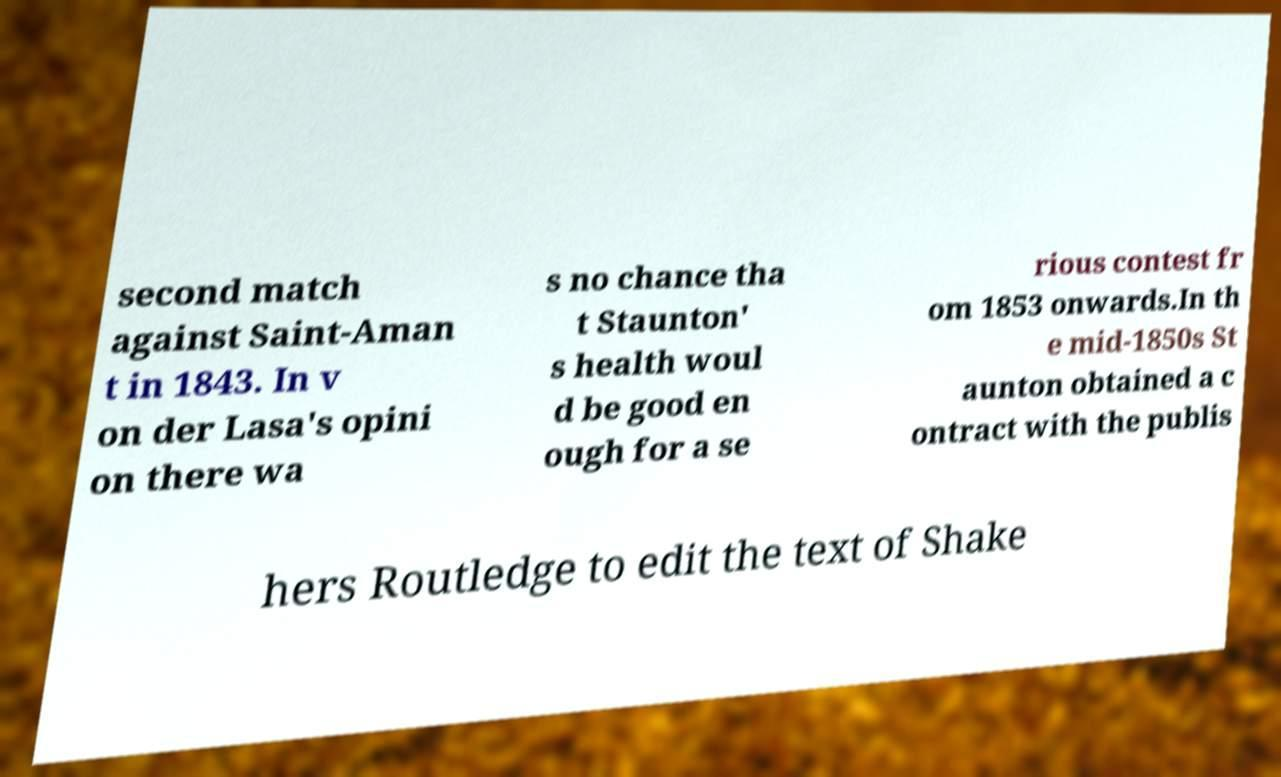Can you accurately transcribe the text from the provided image for me? second match against Saint-Aman t in 1843. In v on der Lasa's opini on there wa s no chance tha t Staunton' s health woul d be good en ough for a se rious contest fr om 1853 onwards.In th e mid-1850s St aunton obtained a c ontract with the publis hers Routledge to edit the text of Shake 